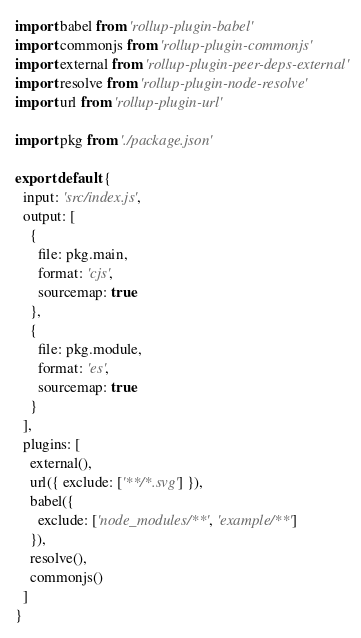Convert code to text. <code><loc_0><loc_0><loc_500><loc_500><_JavaScript_>import babel from 'rollup-plugin-babel'
import commonjs from 'rollup-plugin-commonjs'
import external from 'rollup-plugin-peer-deps-external'
import resolve from 'rollup-plugin-node-resolve'
import url from 'rollup-plugin-url'

import pkg from './package.json'

export default {
  input: 'src/index.js',
  output: [
    {
      file: pkg.main,
      format: 'cjs',
      sourcemap: true
    },
    {
      file: pkg.module,
      format: 'es',
      sourcemap: true
    }
  ],
  plugins: [
    external(),
    url({ exclude: ['**/*.svg'] }),
    babel({
      exclude: ['node_modules/**', 'example/**']
    }),
    resolve(),
    commonjs()
  ]
}
</code> 